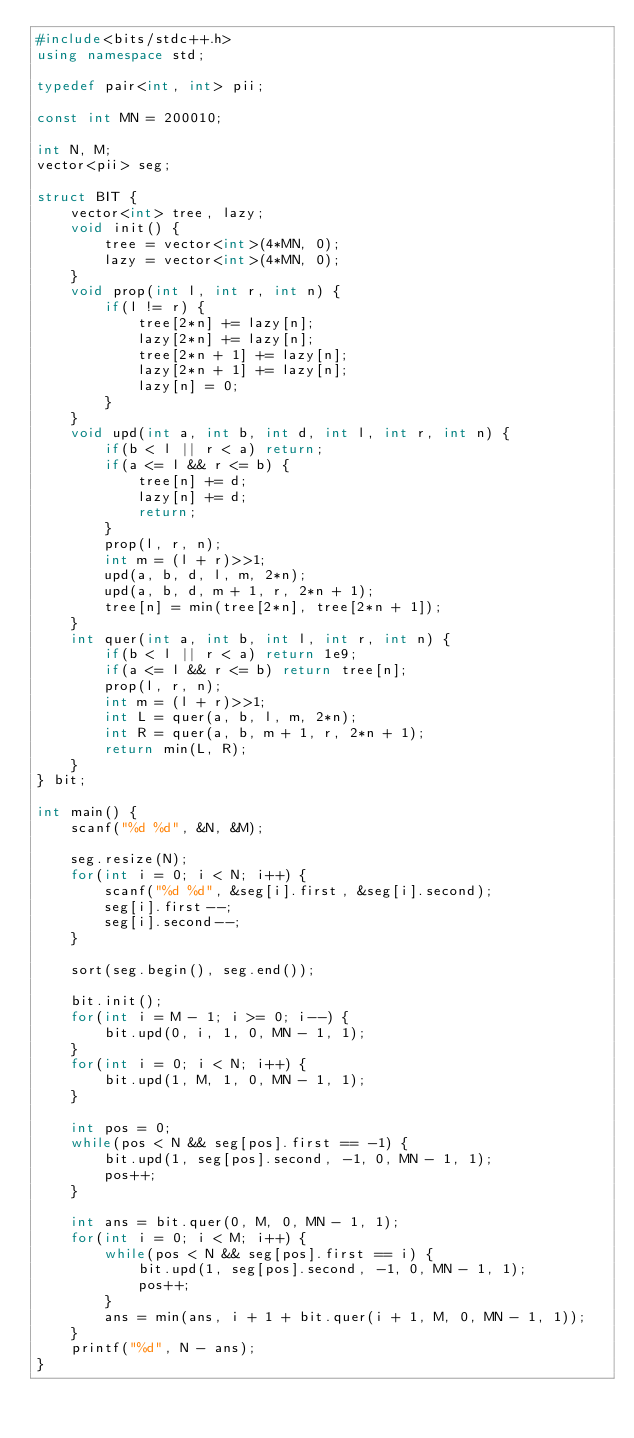Convert code to text. <code><loc_0><loc_0><loc_500><loc_500><_C++_>#include<bits/stdc++.h>
using namespace std;

typedef pair<int, int> pii;

const int MN = 200010;

int N, M;
vector<pii> seg;

struct BIT {
    vector<int> tree, lazy;
    void init() {
        tree = vector<int>(4*MN, 0);
        lazy = vector<int>(4*MN, 0);
    }
    void prop(int l, int r, int n) {
        if(l != r) {
            tree[2*n] += lazy[n];
            lazy[2*n] += lazy[n];
            tree[2*n + 1] += lazy[n];
            lazy[2*n + 1] += lazy[n];
            lazy[n] = 0;
        }
    }
    void upd(int a, int b, int d, int l, int r, int n) {
        if(b < l || r < a) return;
        if(a <= l && r <= b) {
            tree[n] += d;
            lazy[n] += d;
            return;
        }
        prop(l, r, n);
        int m = (l + r)>>1;
        upd(a, b, d, l, m, 2*n);
        upd(a, b, d, m + 1, r, 2*n + 1);
        tree[n] = min(tree[2*n], tree[2*n + 1]);
    }
    int quer(int a, int b, int l, int r, int n) {
        if(b < l || r < a) return 1e9;
        if(a <= l && r <= b) return tree[n];
        prop(l, r, n);
        int m = (l + r)>>1;
        int L = quer(a, b, l, m, 2*n);
        int R = quer(a, b, m + 1, r, 2*n + 1);
        return min(L, R);
    }
} bit;

int main() {
    scanf("%d %d", &N, &M);

    seg.resize(N);
    for(int i = 0; i < N; i++) {
        scanf("%d %d", &seg[i].first, &seg[i].second);
        seg[i].first--;
        seg[i].second--;
    }

    sort(seg.begin(), seg.end());

    bit.init();
    for(int i = M - 1; i >= 0; i--) {
        bit.upd(0, i, 1, 0, MN - 1, 1);
    }
    for(int i = 0; i < N; i++) {
        bit.upd(1, M, 1, 0, MN - 1, 1);
    }

    int pos = 0;
    while(pos < N && seg[pos].first == -1) {
        bit.upd(1, seg[pos].second, -1, 0, MN - 1, 1);
        pos++;
    }

    int ans = bit.quer(0, M, 0, MN - 1, 1);
    for(int i = 0; i < M; i++) {
        while(pos < N && seg[pos].first == i) {
            bit.upd(1, seg[pos].second, -1, 0, MN - 1, 1);
            pos++;
        }
        ans = min(ans, i + 1 + bit.quer(i + 1, M, 0, MN - 1, 1));
    }
    printf("%d", N - ans);
}
</code> 